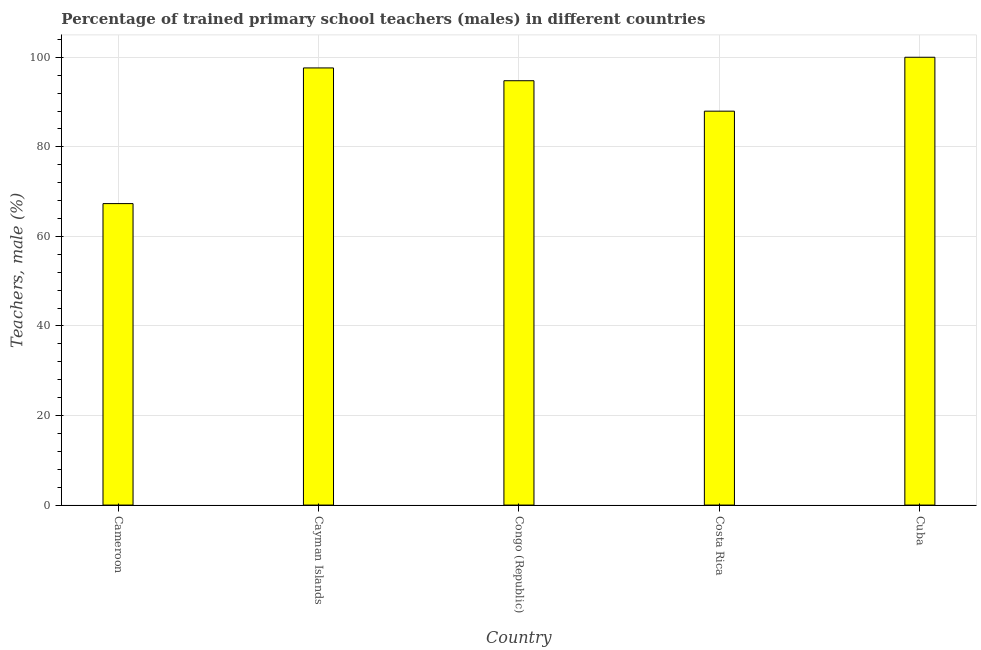What is the title of the graph?
Offer a terse response. Percentage of trained primary school teachers (males) in different countries. What is the label or title of the Y-axis?
Ensure brevity in your answer.  Teachers, male (%). What is the percentage of trained male teachers in Congo (Republic)?
Offer a terse response. 94.76. Across all countries, what is the minimum percentage of trained male teachers?
Make the answer very short. 67.32. In which country was the percentage of trained male teachers maximum?
Offer a terse response. Cuba. In which country was the percentage of trained male teachers minimum?
Make the answer very short. Cameroon. What is the sum of the percentage of trained male teachers?
Provide a succinct answer. 447.67. What is the difference between the percentage of trained male teachers in Cameroon and Congo (Republic)?
Give a very brief answer. -27.44. What is the average percentage of trained male teachers per country?
Your answer should be compact. 89.53. What is the median percentage of trained male teachers?
Your response must be concise. 94.76. What is the ratio of the percentage of trained male teachers in Cameroon to that in Cuba?
Keep it short and to the point. 0.67. Is the difference between the percentage of trained male teachers in Cameroon and Cayman Islands greater than the difference between any two countries?
Provide a succinct answer. No. What is the difference between the highest and the second highest percentage of trained male teachers?
Give a very brief answer. 2.38. What is the difference between the highest and the lowest percentage of trained male teachers?
Make the answer very short. 32.68. In how many countries, is the percentage of trained male teachers greater than the average percentage of trained male teachers taken over all countries?
Make the answer very short. 3. How many bars are there?
Ensure brevity in your answer.  5. How many countries are there in the graph?
Give a very brief answer. 5. Are the values on the major ticks of Y-axis written in scientific E-notation?
Your answer should be very brief. No. What is the Teachers, male (%) of Cameroon?
Provide a short and direct response. 67.32. What is the Teachers, male (%) in Cayman Islands?
Provide a succinct answer. 97.62. What is the Teachers, male (%) of Congo (Republic)?
Offer a very short reply. 94.76. What is the Teachers, male (%) in Costa Rica?
Ensure brevity in your answer.  87.96. What is the Teachers, male (%) in Cuba?
Offer a very short reply. 100. What is the difference between the Teachers, male (%) in Cameroon and Cayman Islands?
Provide a short and direct response. -30.3. What is the difference between the Teachers, male (%) in Cameroon and Congo (Republic)?
Offer a terse response. -27.44. What is the difference between the Teachers, male (%) in Cameroon and Costa Rica?
Make the answer very short. -20.64. What is the difference between the Teachers, male (%) in Cameroon and Cuba?
Offer a terse response. -32.68. What is the difference between the Teachers, male (%) in Cayman Islands and Congo (Republic)?
Provide a short and direct response. 2.86. What is the difference between the Teachers, male (%) in Cayman Islands and Costa Rica?
Your answer should be compact. 9.66. What is the difference between the Teachers, male (%) in Cayman Islands and Cuba?
Your response must be concise. -2.38. What is the difference between the Teachers, male (%) in Congo (Republic) and Costa Rica?
Keep it short and to the point. 6.8. What is the difference between the Teachers, male (%) in Congo (Republic) and Cuba?
Offer a terse response. -5.24. What is the difference between the Teachers, male (%) in Costa Rica and Cuba?
Provide a short and direct response. -12.04. What is the ratio of the Teachers, male (%) in Cameroon to that in Cayman Islands?
Your answer should be very brief. 0.69. What is the ratio of the Teachers, male (%) in Cameroon to that in Congo (Republic)?
Ensure brevity in your answer.  0.71. What is the ratio of the Teachers, male (%) in Cameroon to that in Costa Rica?
Give a very brief answer. 0.77. What is the ratio of the Teachers, male (%) in Cameroon to that in Cuba?
Keep it short and to the point. 0.67. What is the ratio of the Teachers, male (%) in Cayman Islands to that in Congo (Republic)?
Your response must be concise. 1.03. What is the ratio of the Teachers, male (%) in Cayman Islands to that in Costa Rica?
Your answer should be very brief. 1.11. What is the ratio of the Teachers, male (%) in Cayman Islands to that in Cuba?
Your answer should be very brief. 0.98. What is the ratio of the Teachers, male (%) in Congo (Republic) to that in Costa Rica?
Keep it short and to the point. 1.08. What is the ratio of the Teachers, male (%) in Congo (Republic) to that in Cuba?
Your answer should be very brief. 0.95. What is the ratio of the Teachers, male (%) in Costa Rica to that in Cuba?
Give a very brief answer. 0.88. 